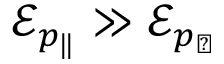Convert formula to latex. <formula><loc_0><loc_0><loc_500><loc_500>\mathcal { E } _ { p _ { \| } } \gg \mathcal { E } _ { p _ { \perp } }</formula> 